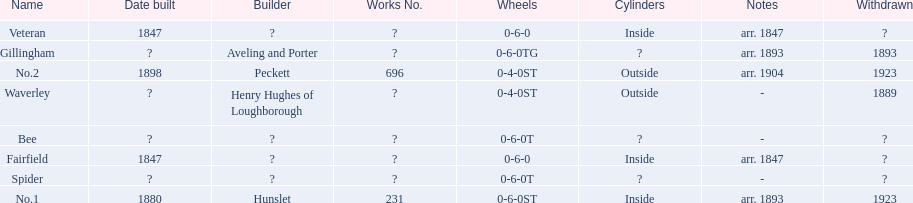What are the alderney railway names? Veteran, Fairfield, Waverley, Bee, Spider, Gillingham, No.1, No.2. When was the farfield built? 1847. What else was built that year? Veteran. 